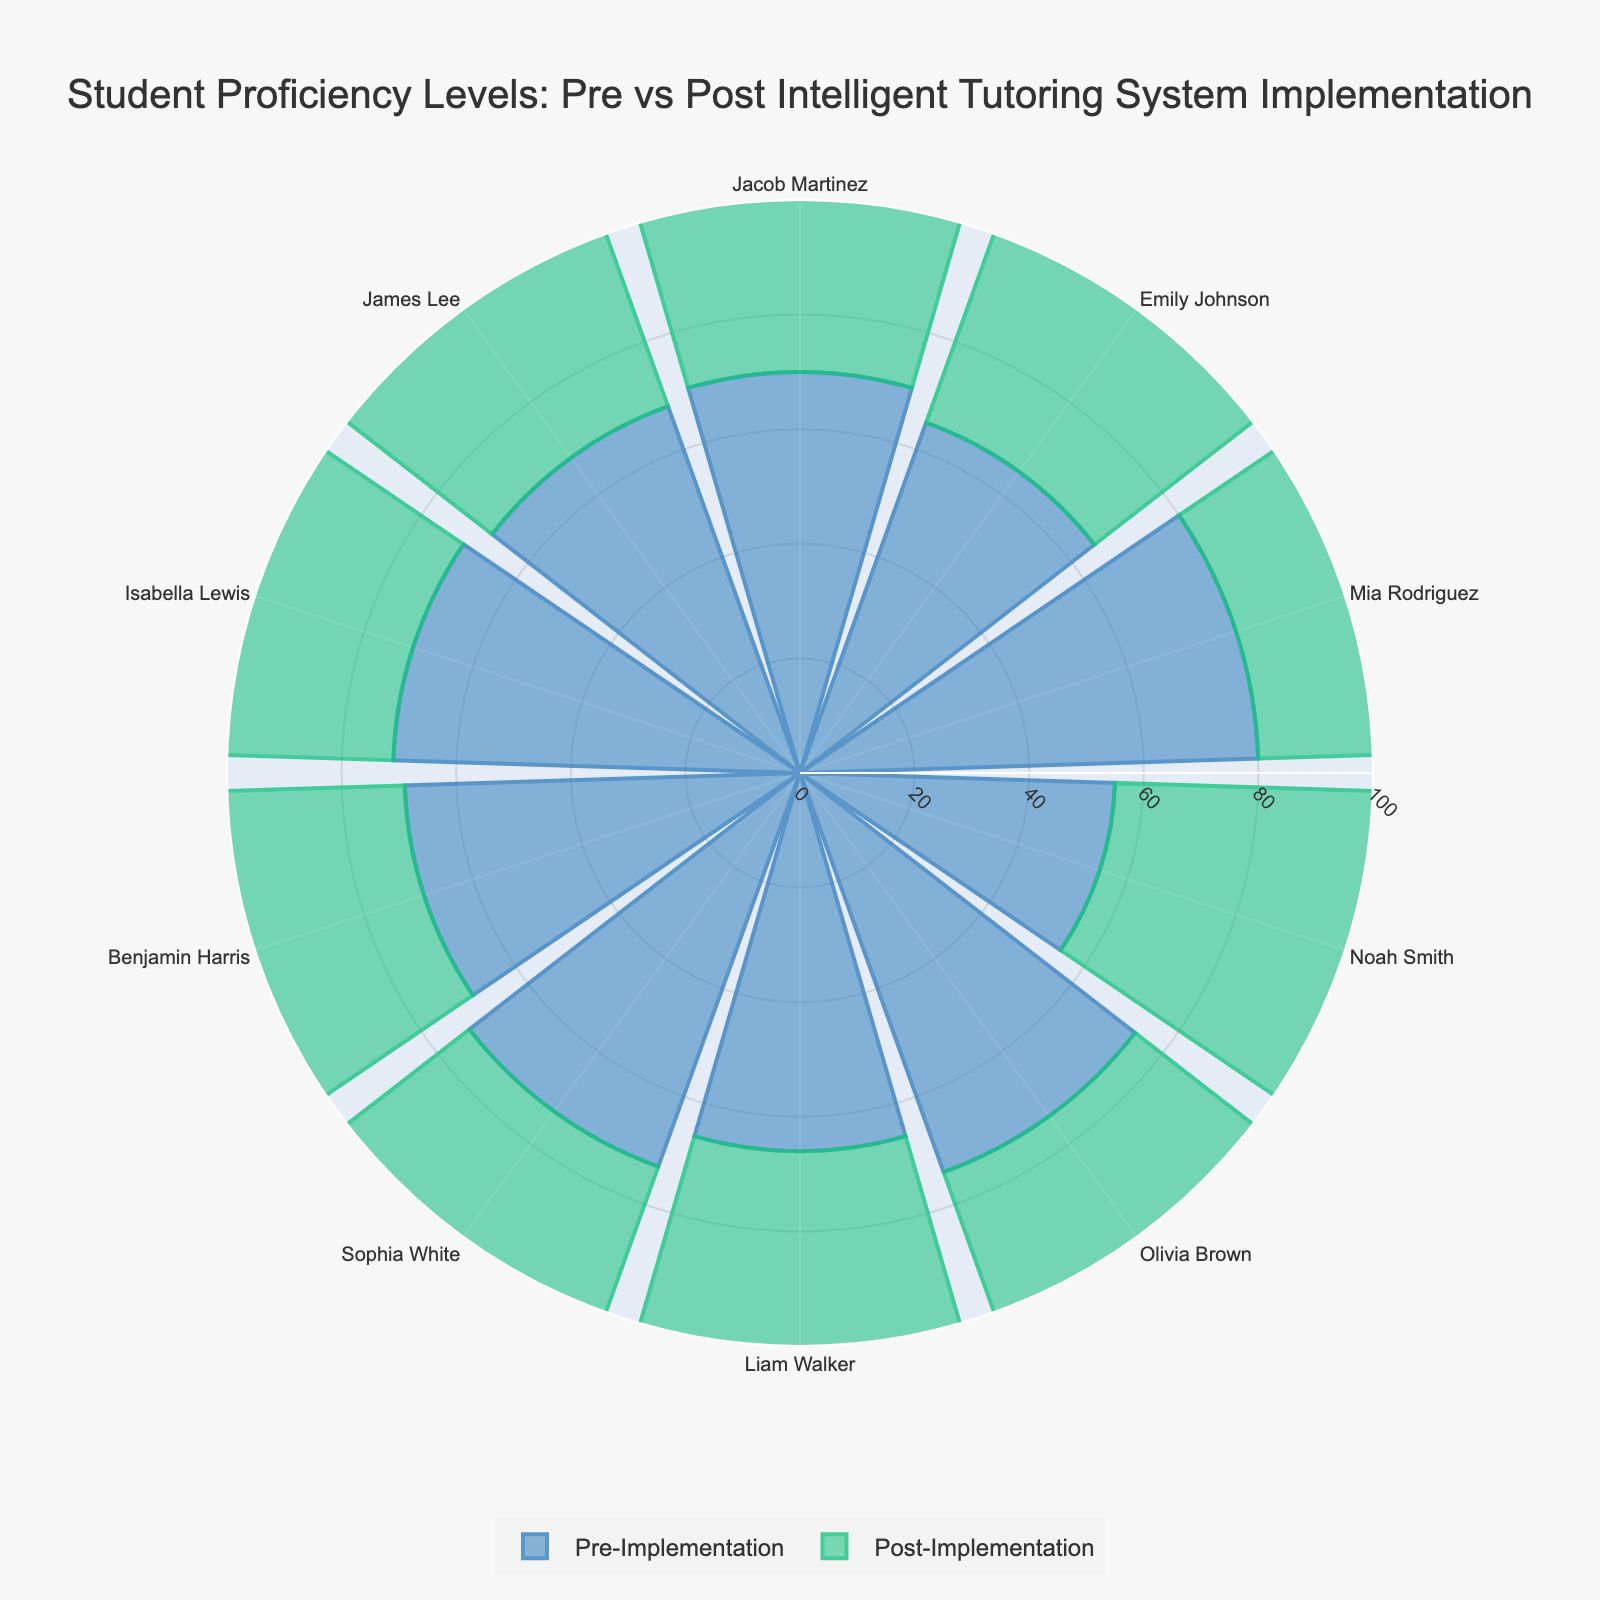What is the title of the chart? The title of the chart is displayed at the top and represents the topic the chart is visualizing.
Answer: Student Proficiency Levels: Pre vs Post Intelligent Tutoring System Implementation How many students are represented in the chart? By counting the labels on the angular axis, you can determine the number of students shown in the chart.
Answer: 10 Which student showed the highest proficiency after the implementation? By identifying the longest bar in the 'Post-Implementation' section, you can pinpoint the student with the highest proficiency. In this case, it is labeled "Mia Rodriguez".
Answer: Mia Rodriguez What is the difference in proficiency for Jacob Martinez before and after the implementation? Find the lengths of the bars for Jacob Martinez in both 'Pre-Implementation' and 'Post-Implementation' sections, then subtract the pre-implementation score from the post-implementation score. (85 - 70 = 15)
Answer: 15 Which student showed the least improvement in proficiency? Calculate the improvement for each student by subtracting their pre-implementation score from their post-implementation score, and find the smallest value. Noah Smith: 72-55 = 17, the least improvement of 17 points.
Answer: Noah Smith What is the average pre-implementation proficiency score? Sum all pre-implementation scores and then divide by the number of students. (70 + 65 + 80 + 55 + 74 + 66 + 73 + 69 + 71 + 68) / 10 = 69.1
Answer: 69.1 Is there any student who achieved the same proficiency level pre- and post-implementation? Compare the bars for each student between pre- and post-implementation. There is no student with bars of equal length in both sections.
Answer: No Which color represents post-implementation proficiency scores? Look at the legend and identify the color coded for post-implementation. The color is marked as 'rgba(26, 196, 130, 0.7)' in the code and visually observed on the chart.
Answer: Green What is the total combined increase in proficiency across all students? Subtract pre-implementation scores from post-implementation scores for all students and then sum the differences. (15 + 13 + 10 + 17 + 14 + 13 + 16 + 13 + 16 + 13 = 140)
Answer: 140 Which student had the highest improvement in their proficiency and by how much? By calculation and comparison, find the student with the maximum score increase. Jacob Martinez: 15, Emily Johnson: 13, Mia Rodriguez: 10, Noah Smith: 17, Olivia Brown: 14, Liam Walker: 13, Sophia White: 16, Benjamin Harris: 13, Isabella Lewis: 16, James Lee: 13. Noah Smith: 17, the highest improvement by 17 points.
Answer: Noah Smith, 17 points 